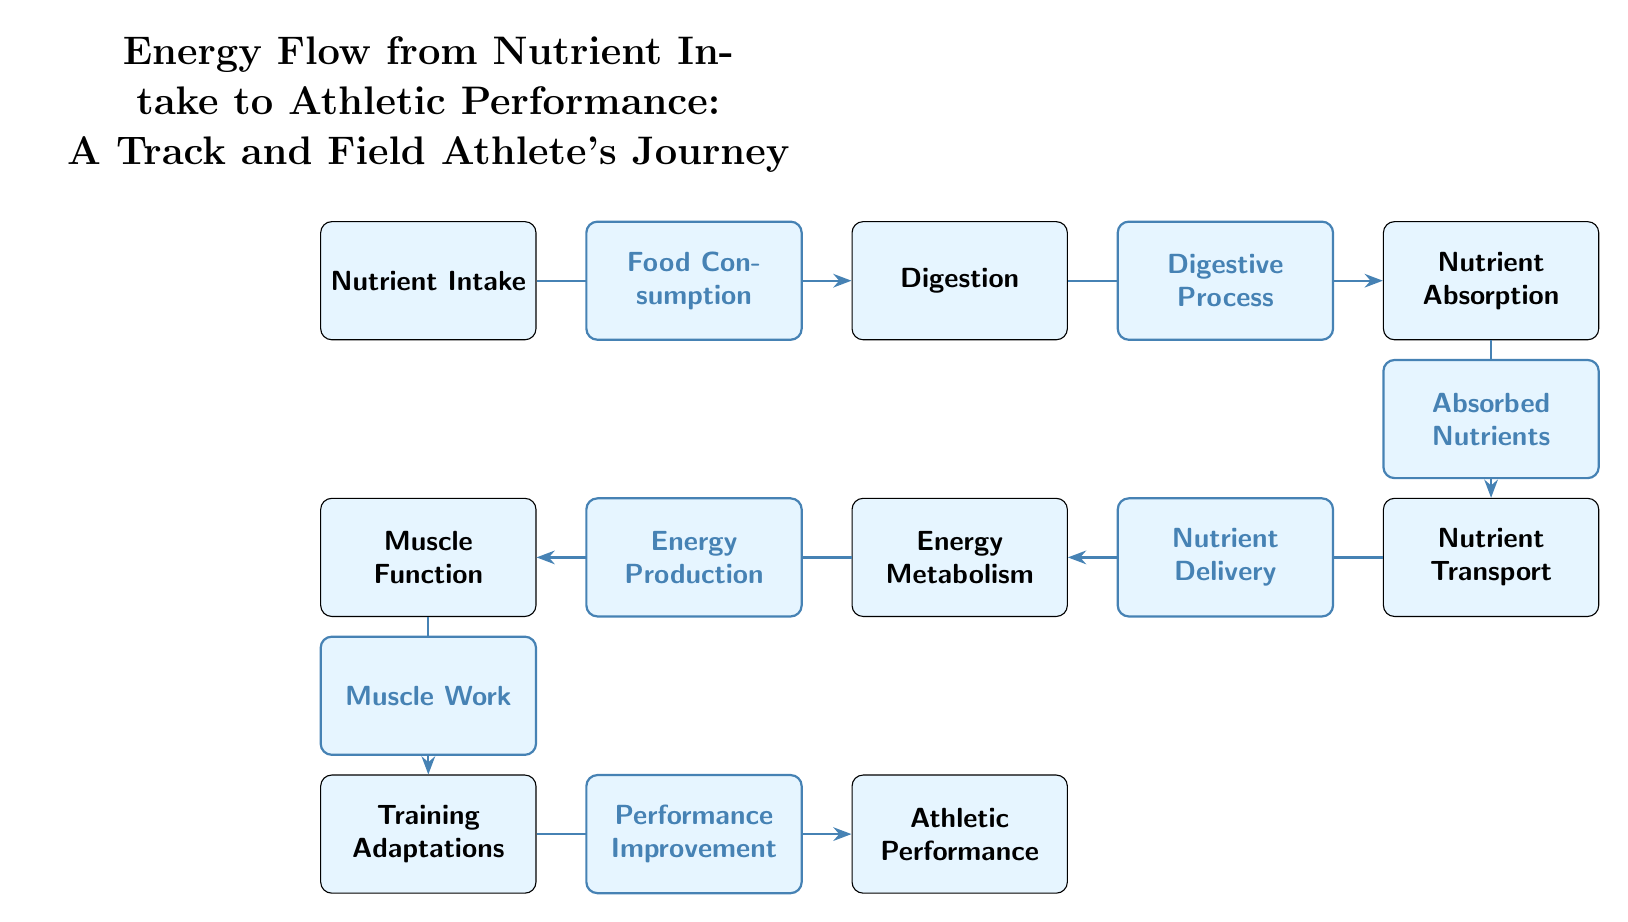What is the first step in the energy flow process? The diagram starts with the node labeled 'Nutrient Intake', which represents the first step where an athlete consumes food.
Answer: Nutrient Intake How many nodes are there in the diagram? The diagram includes a total of six distinct nodes: Nutrient Intake, Digestion, Nutrient Absorption, Nutrient Transport, Energy Metabolism, Muscle Function, Training Adaptations, and Athletic Performance, resulting in eight nodes in total.
Answer: 8 What is the connection between 'Muscle Function' and 'Training Adaptations'? 'Muscle Function' leads to 'Training Adaptations', indicating that the functioning of muscles contributes to adaptations that occur from training.
Answer: Muscle Work What process follows 'Nutrient Absorption' in the flow? After 'Nutrient Absorption', the next step is 'Nutrient Transport', showing the delivery of absorbed nutrients to the body.
Answer: Nutrient Transport Which node does 'Energy Metabolism' directly connect to? 'Energy Metabolism' directly connects to 'Muscle Function', indicating that energy produced is utilized by muscle functions.
Answer: Muscle Function What leads to 'Athletic Performance'? 'Training Adaptations' lead to 'Athletic Performance', suggesting that the adaptations from training result in the improvement of performance.
Answer: Performance Improvement How does 'Digestion' relate to 'Nutrient Absorption'? 'Digestion' leads to 'Nutrient Absorption', demonstrating that the digestive process is essential for the absorption of nutrients.
Answer: Digestive Process What type of node is positioned directly below 'Nutrient Absorption'? The node directly below 'Nutrient Absorption' is 'Nutrient Transport', indicating a sequential flow of processes.
Answer: Nutrient Transport 